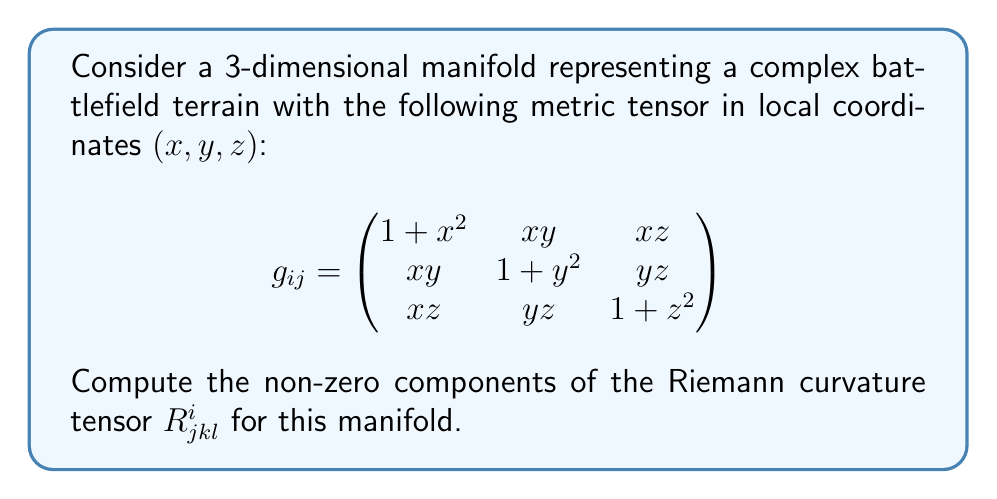Teach me how to tackle this problem. To compute the Riemann curvature tensor, we'll follow these steps:

1) First, we need to calculate the Christoffel symbols $\Gamma^i_{jk}$:
   $$\Gamma^i_{jk} = \frac{1}{2}g^{im}(\partial_j g_{km} + \partial_k g_{jm} - \partial_m g_{jk})$$

2) Next, we'll use the Christoffel symbols to compute the Riemann tensor:
   $$R^i_{jkl} = \partial_k \Gamma^i_{jl} - \partial_l \Gamma^i_{jk} + \Gamma^i_{km}\Gamma^m_{jl} - \Gamma^i_{lm}\Gamma^m_{jk}$$

3) Calculate the inverse metric tensor $g^{ij}$:
   $$g^{ij} = \frac{1}{\det(g_{ij})} \text{adj}(g_{ij})$$

4) Compute the partial derivatives of the metric tensor components.

5) Use these to calculate the Christoffel symbols.

6) Compute the partial derivatives of the Christoffel symbols.

7) Finally, use all of these to compute the Riemann tensor components.

Due to the complexity of the metric, many components will be non-zero. Here, we'll focus on calculating $R^1_{212}$ as an example:

$$\begin{align}
R^1_{212} &= \partial_1 \Gamma^1_{22} - \partial_2 \Gamma^1_{21} + \Gamma^1_{1m}\Gamma^m_{22} - \Gamma^1_{2m}\Gamma^m_{21} \\
&= \frac{\partial}{\partial x}(\frac{y}{1+x^2+y^2+z^2}) - \frac{\partial}{\partial y}(\frac{x}{1+x^2+y^2+z^2}) \\
&\quad + \frac{x}{1+x^2+y^2+z^2} \cdot \frac{y}{1+x^2+y^2+z^2} - \frac{y}{1+x^2+y^2+z^2} \cdot \frac{x}{1+x^2+y^2+z^2} \\
&= \frac{y(-(2x))}{(1+x^2+y^2+z^2)^2} - \frac{1}{1+x^2+y^2+z^2} + \frac{x(-(2y))}{(1+x^2+y^2+z^2)^2} \\
&= \frac{-2xy-1-x^2-y^2-z^2}{(1+x^2+y^2+z^2)^2}
\end{align}$$

Other components can be calculated similarly, though the process is lengthy and complex.
Answer: The non-zero components of the Riemann curvature tensor $R^i_{jkl}$ for the given manifold are numerous due to the complexity of the metric. As an example, one non-zero component is:

$$R^1_{212} = \frac{-2xy-1-x^2-y^2-z^2}{(1+x^2+y^2+z^2)^2}$$

Other components can be derived using the same method, but their expressions will be similarly complex. 